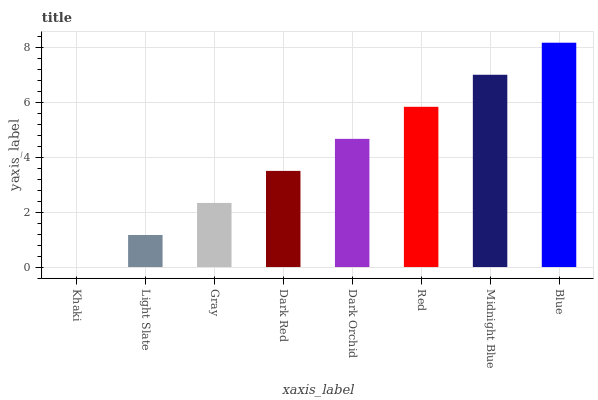Is Blue the maximum?
Answer yes or no. Yes. Is Light Slate the minimum?
Answer yes or no. No. Is Light Slate the maximum?
Answer yes or no. No. Is Light Slate greater than Khaki?
Answer yes or no. Yes. Is Khaki less than Light Slate?
Answer yes or no. Yes. Is Khaki greater than Light Slate?
Answer yes or no. No. Is Light Slate less than Khaki?
Answer yes or no. No. Is Dark Orchid the high median?
Answer yes or no. Yes. Is Dark Red the low median?
Answer yes or no. Yes. Is Gray the high median?
Answer yes or no. No. Is Midnight Blue the low median?
Answer yes or no. No. 